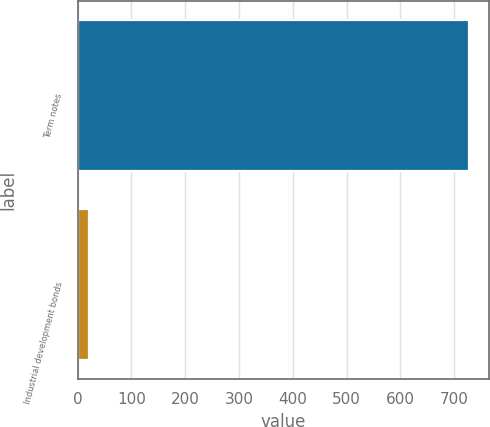<chart> <loc_0><loc_0><loc_500><loc_500><bar_chart><fcel>Term notes<fcel>Industrial development bonds<nl><fcel>728.1<fcel>20.9<nl></chart> 